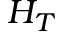<formula> <loc_0><loc_0><loc_500><loc_500>H _ { T }</formula> 